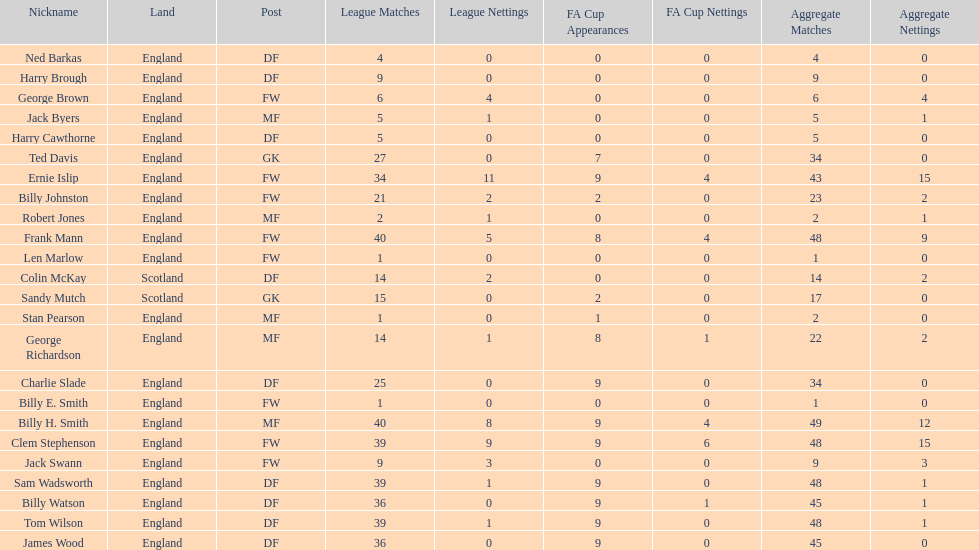What is the average number of scotland's total apps? 15.5. 